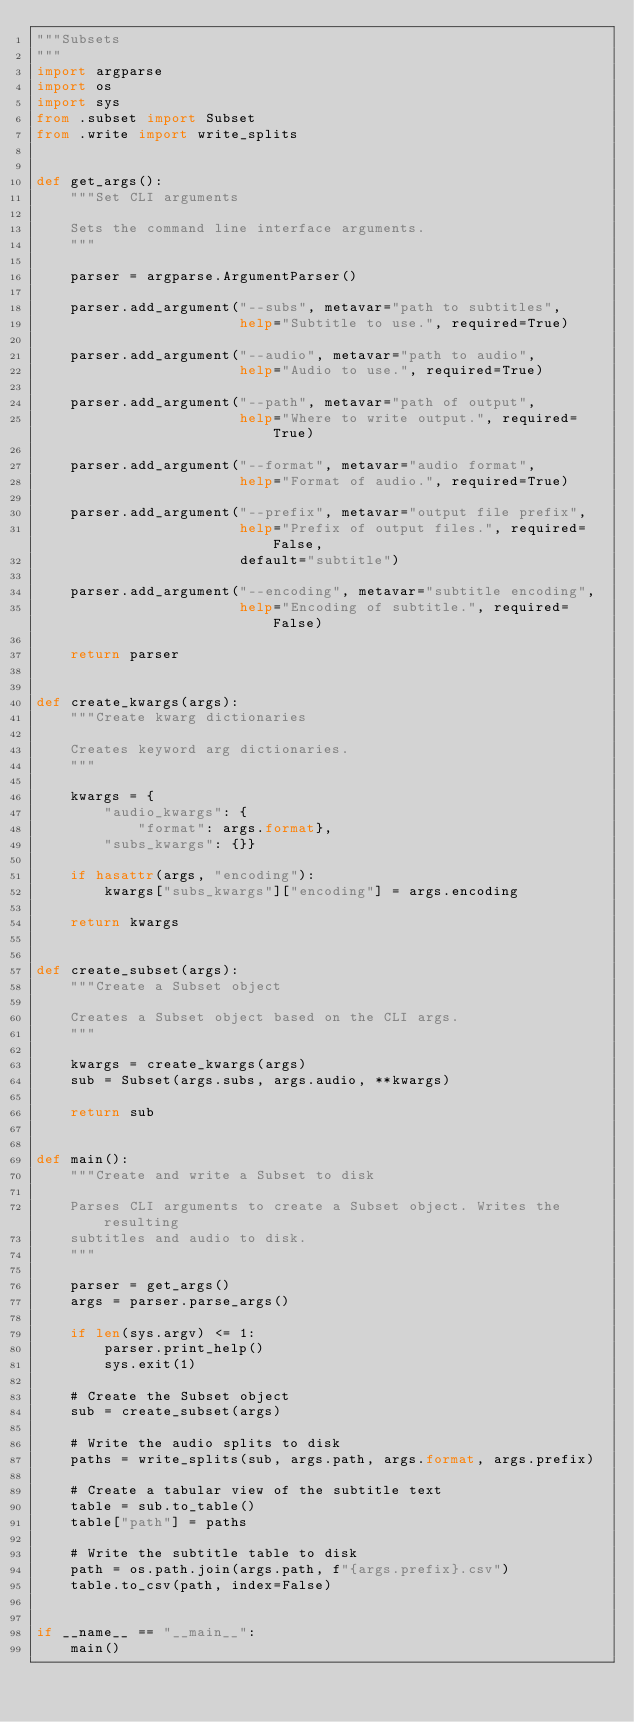<code> <loc_0><loc_0><loc_500><loc_500><_Python_>"""Subsets
"""
import argparse
import os
import sys
from .subset import Subset
from .write import write_splits


def get_args():
    """Set CLI arguments

    Sets the command line interface arguments.
    """

    parser = argparse.ArgumentParser()

    parser.add_argument("--subs", metavar="path to subtitles",
                        help="Subtitle to use.", required=True)

    parser.add_argument("--audio", metavar="path to audio",
                        help="Audio to use.", required=True)

    parser.add_argument("--path", metavar="path of output",
                        help="Where to write output.", required=True)

    parser.add_argument("--format", metavar="audio format",
                        help="Format of audio.", required=True)

    parser.add_argument("--prefix", metavar="output file prefix",
                        help="Prefix of output files.", required=False,
                        default="subtitle")

    parser.add_argument("--encoding", metavar="subtitle encoding",
                        help="Encoding of subtitle.", required=False)

    return parser


def create_kwargs(args):
    """Create kwarg dictionaries

    Creates keyword arg dictionaries.
    """

    kwargs = {
        "audio_kwargs": {
            "format": args.format},
        "subs_kwargs": {}}

    if hasattr(args, "encoding"):
        kwargs["subs_kwargs"]["encoding"] = args.encoding

    return kwargs


def create_subset(args):
    """Create a Subset object

    Creates a Subset object based on the CLI args.
    """

    kwargs = create_kwargs(args)
    sub = Subset(args.subs, args.audio, **kwargs)

    return sub


def main():
    """Create and write a Subset to disk

    Parses CLI arguments to create a Subset object. Writes the resulting
    subtitles and audio to disk.
    """

    parser = get_args()
    args = parser.parse_args()

    if len(sys.argv) <= 1:
        parser.print_help()
        sys.exit(1)

    # Create the Subset object
    sub = create_subset(args)

    # Write the audio splits to disk
    paths = write_splits(sub, args.path, args.format, args.prefix)

    # Create a tabular view of the subtitle text
    table = sub.to_table()
    table["path"] = paths

    # Write the subtitle table to disk
    path = os.path.join(args.path, f"{args.prefix}.csv")
    table.to_csv(path, index=False)


if __name__ == "__main__":
    main()
</code> 